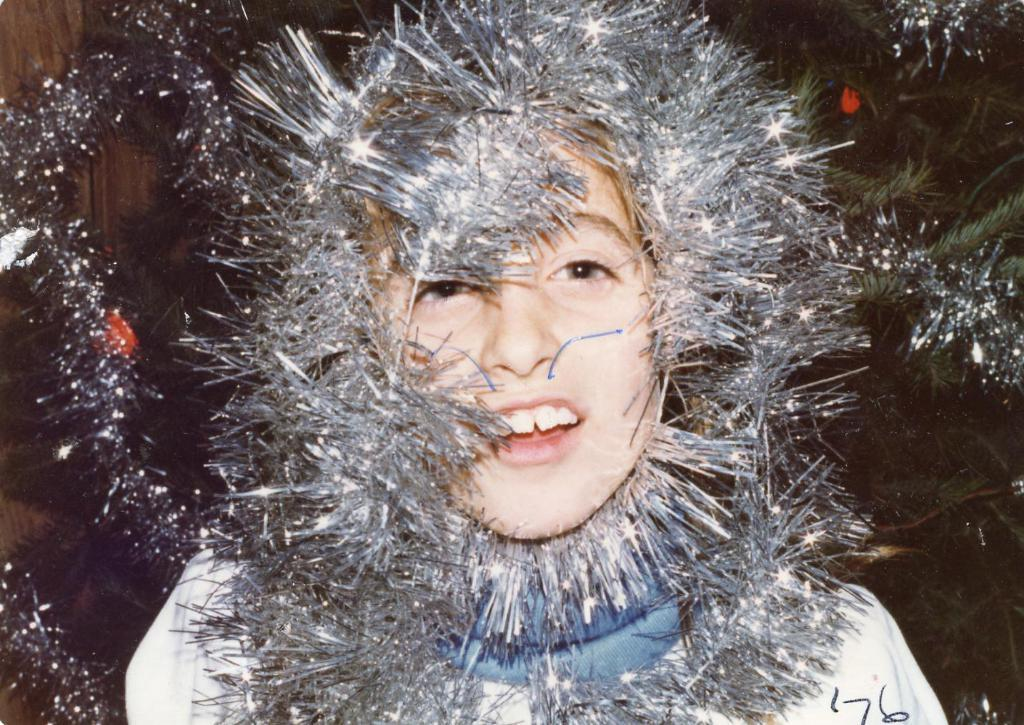Who or what is present in the image? There is a person in the image. What is the person wearing in the image? The person is wearing a decorative item. What can be seen in the background of the image? There is a Christmas tree in the background of the image. What type of tank can be seen in the image? There is no tank present in the image. What teeth can be seen in the image? There are no teeth visible in the image. 